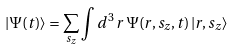<formula> <loc_0><loc_0><loc_500><loc_500>| \Psi ( t ) \rangle = \sum _ { s _ { z } } \int d ^ { 3 } \, r \, \Psi ( r , s _ { z } , t ) \, | r , s _ { z } \rangle</formula> 